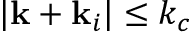Convert formula to latex. <formula><loc_0><loc_0><loc_500><loc_500>| k + k _ { i } | \leq k _ { c }</formula> 